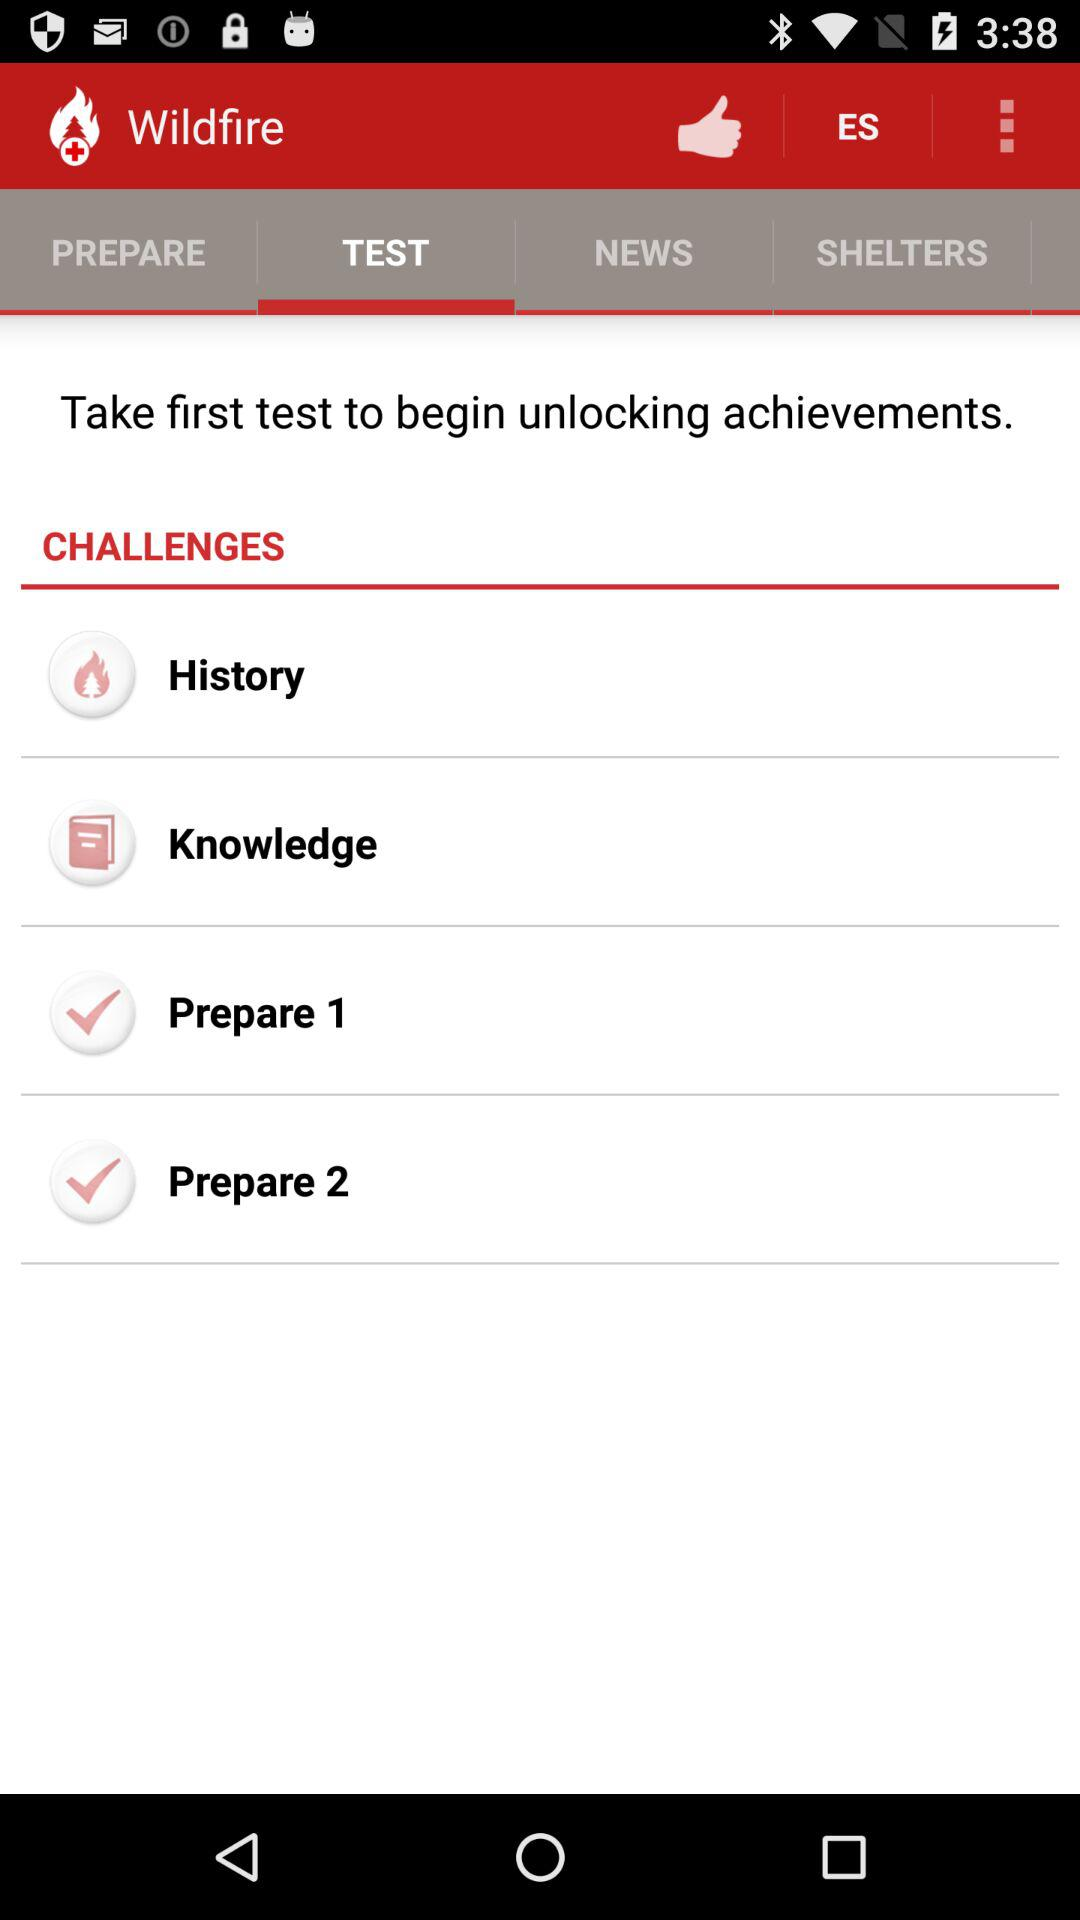Which are the different options in "CHALLENGES"? The different options are "History", "Knowledge", "Prepare 1" and "Prepare 2". 